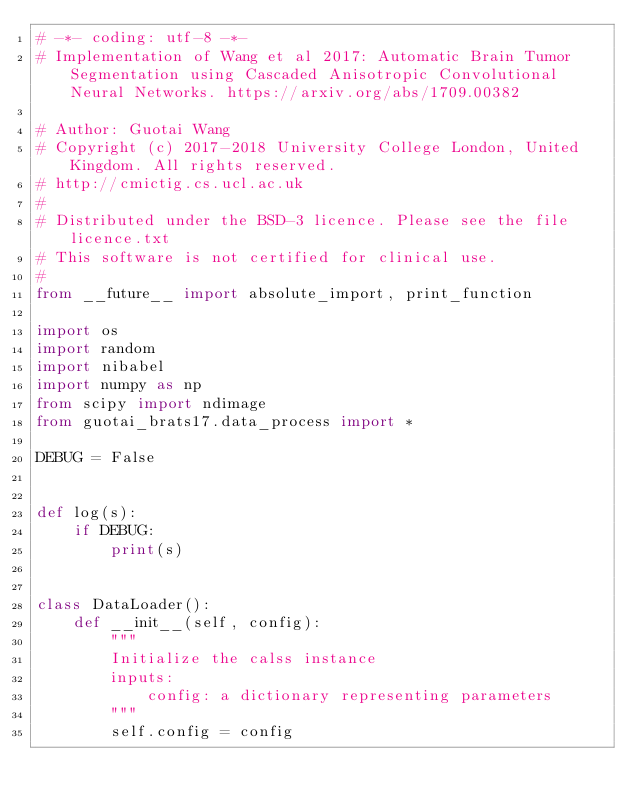Convert code to text. <code><loc_0><loc_0><loc_500><loc_500><_Python_># -*- coding: utf-8 -*-
# Implementation of Wang et al 2017: Automatic Brain Tumor Segmentation using Cascaded Anisotropic Convolutional Neural Networks. https://arxiv.org/abs/1709.00382

# Author: Guotai Wang
# Copyright (c) 2017-2018 University College London, United Kingdom. All rights reserved.
# http://cmictig.cs.ucl.ac.uk
#
# Distributed under the BSD-3 licence. Please see the file licence.txt
# This software is not certified for clinical use.
#
from __future__ import absolute_import, print_function

import os
import random
import nibabel
import numpy as np
from scipy import ndimage
from guotai_brats17.data_process import *

DEBUG = False


def log(s):
	if DEBUG:
		print(s)


class DataLoader():
	def __init__(self, config):
		"""
		Initialize the calss instance
		inputs:
			config: a dictionary representing parameters
		"""
		self.config = config</code> 